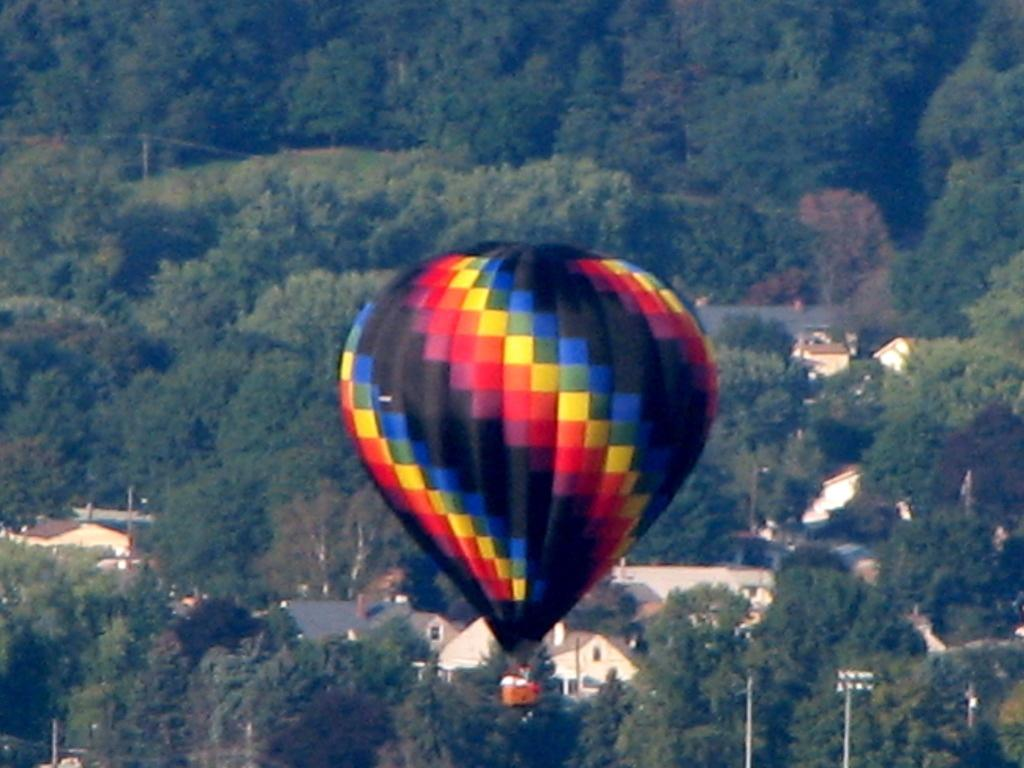What is the main subject of the image? The main subject of the image is an air balloon. Where is the air balloon located in the image? The air balloon is in the air. What can be seen in the background of the image? There are trees, a current pole, and buildings in the background of the image. What type of sound can be heard coming from the air balloon in the image? There is no sound coming from the air balloon in the image, as it is a still image and cannot capture sound. 